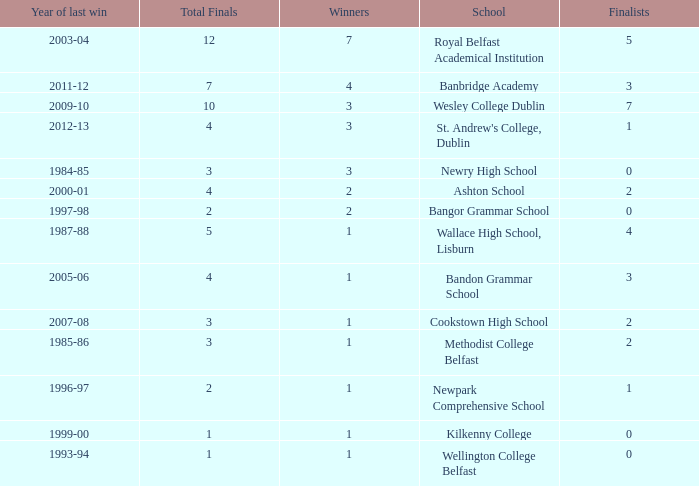What is the name of the school where the year of last win is 1985-86? Methodist College Belfast. 